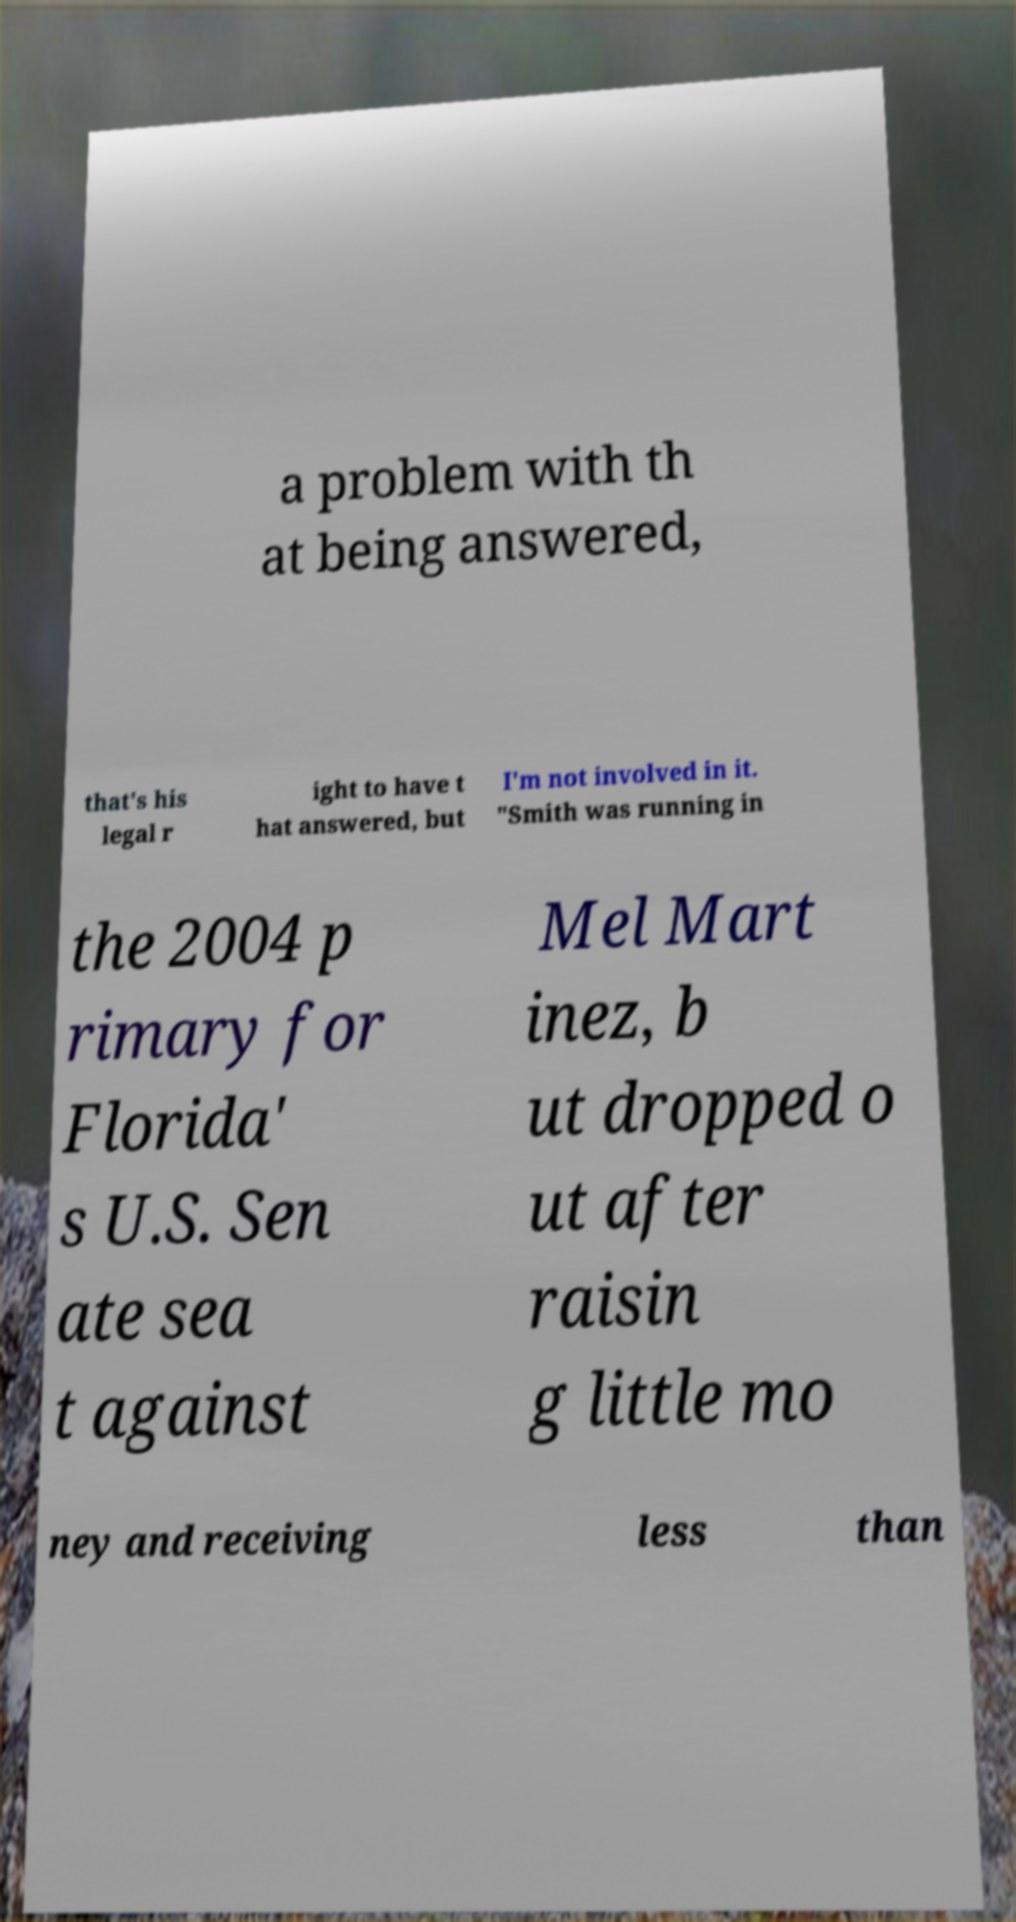Could you assist in decoding the text presented in this image and type it out clearly? a problem with th at being answered, that's his legal r ight to have t hat answered, but I'm not involved in it. "Smith was running in the 2004 p rimary for Florida' s U.S. Sen ate sea t against Mel Mart inez, b ut dropped o ut after raisin g little mo ney and receiving less than 